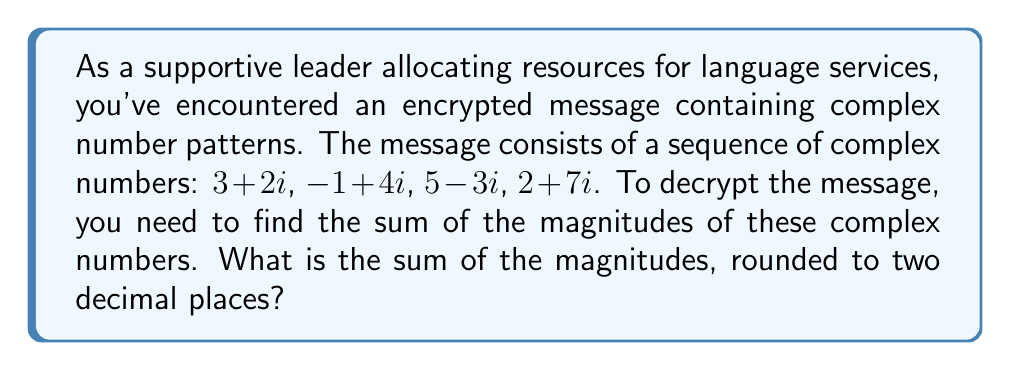Can you solve this math problem? To solve this problem, we need to follow these steps:

1. Calculate the magnitude of each complex number using the formula $|a+bi| = \sqrt{a^2 + b^2}$

2. Sum up all the magnitudes

3. Round the result to two decimal places

Let's calculate the magnitude of each complex number:

For $3+2i$:
$$|3+2i| = \sqrt{3^2 + 2^2} = \sqrt{9 + 4} = \sqrt{13} \approx 3.61$$

For $-1+4i$:
$$|-1+4i| = \sqrt{(-1)^2 + 4^2} = \sqrt{1 + 16} = \sqrt{17} \approx 4.12$$

For $5-3i$:
$$|5-3i| = \sqrt{5^2 + (-3)^2} = \sqrt{25 + 9} = \sqrt{34} \approx 5.83$$

For $2+7i$:
$$|2+7i| = \sqrt{2^2 + 7^2} = \sqrt{4 + 49} = \sqrt{53} \approx 7.28$$

Now, let's sum up all the magnitudes:

$$3.61 + 4.12 + 5.83 + 7.28 = 20.84$$

Rounding to two decimal places, we get 20.84.
Answer: 20.84 